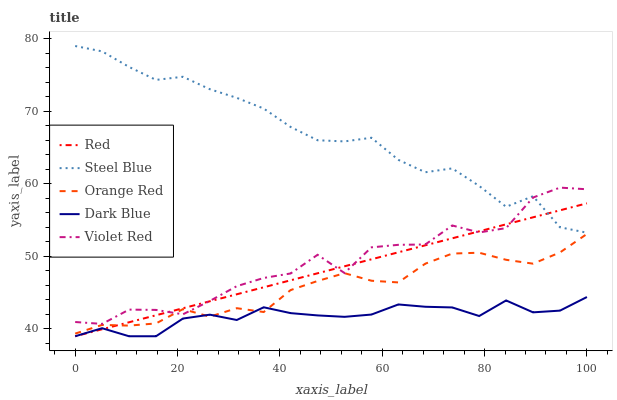Does Dark Blue have the minimum area under the curve?
Answer yes or no. Yes. Does Steel Blue have the maximum area under the curve?
Answer yes or no. Yes. Does Violet Red have the minimum area under the curve?
Answer yes or no. No. Does Violet Red have the maximum area under the curve?
Answer yes or no. No. Is Red the smoothest?
Answer yes or no. Yes. Is Violet Red the roughest?
Answer yes or no. Yes. Is Steel Blue the smoothest?
Answer yes or no. No. Is Steel Blue the roughest?
Answer yes or no. No. Does Violet Red have the lowest value?
Answer yes or no. No. Does Violet Red have the highest value?
Answer yes or no. No. Is Dark Blue less than Steel Blue?
Answer yes or no. Yes. Is Steel Blue greater than Orange Red?
Answer yes or no. Yes. Does Dark Blue intersect Steel Blue?
Answer yes or no. No. 